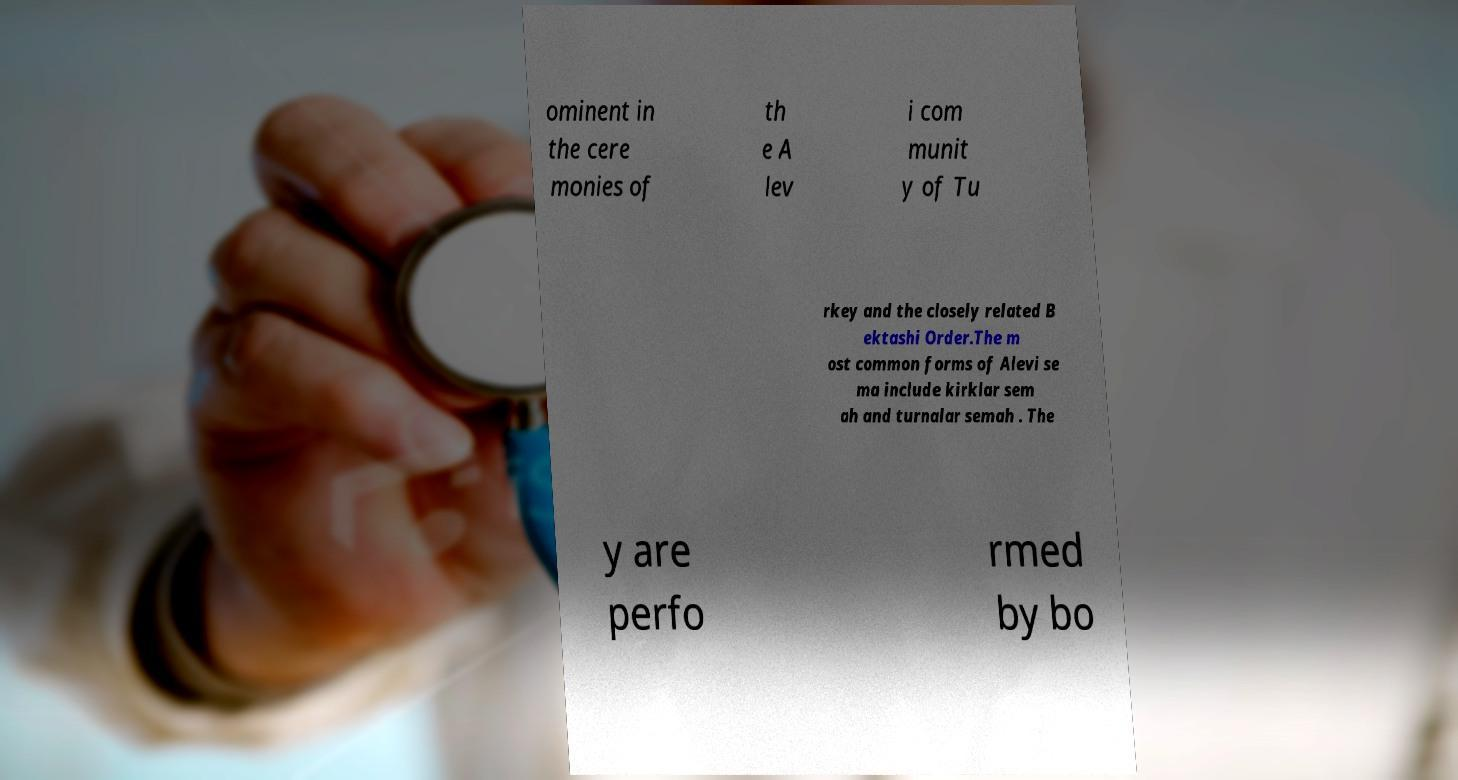What messages or text are displayed in this image? I need them in a readable, typed format. ominent in the cere monies of th e A lev i com munit y of Tu rkey and the closely related B ektashi Order.The m ost common forms of Alevi se ma include kirklar sem ah and turnalar semah . The y are perfo rmed by bo 